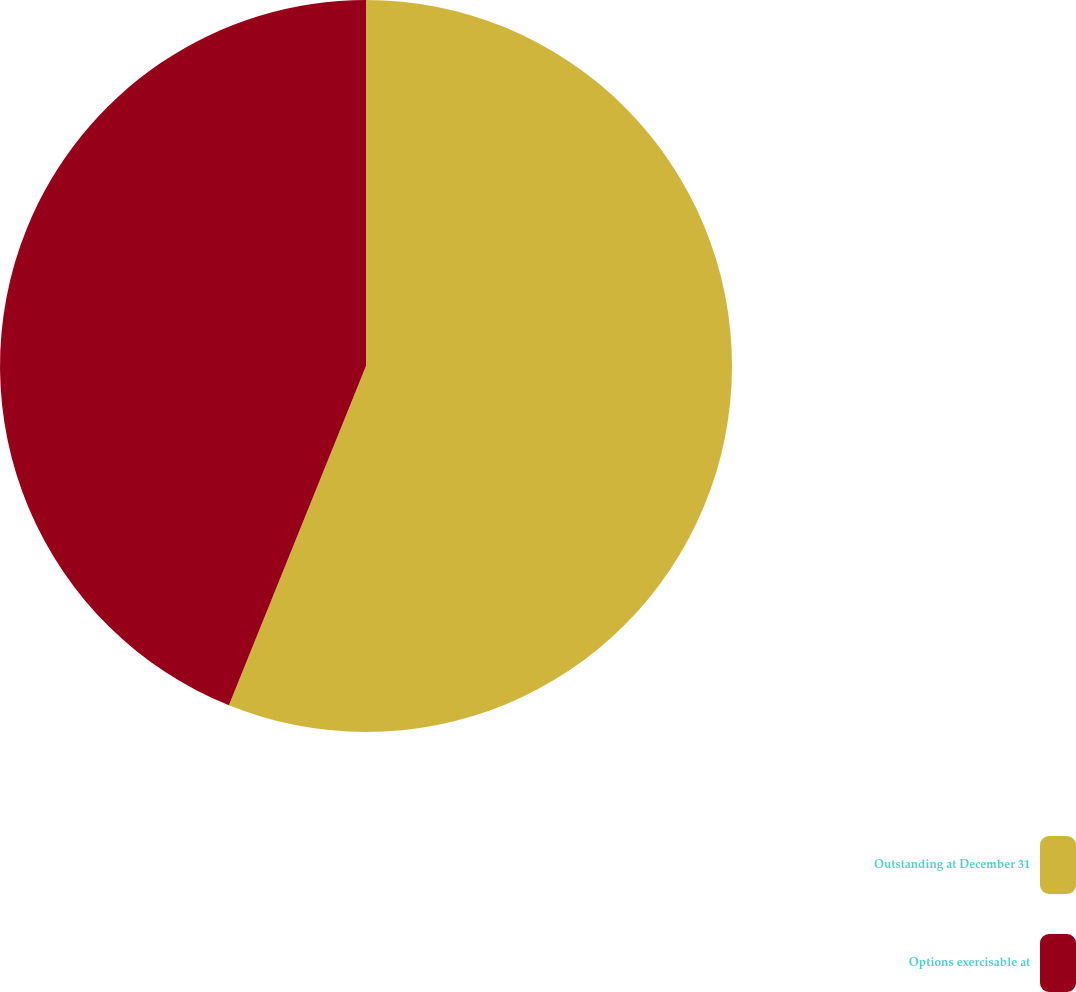Convert chart to OTSL. <chart><loc_0><loc_0><loc_500><loc_500><pie_chart><fcel>Outstanding at December 31<fcel>Options exercisable at<nl><fcel>56.11%<fcel>43.89%<nl></chart> 